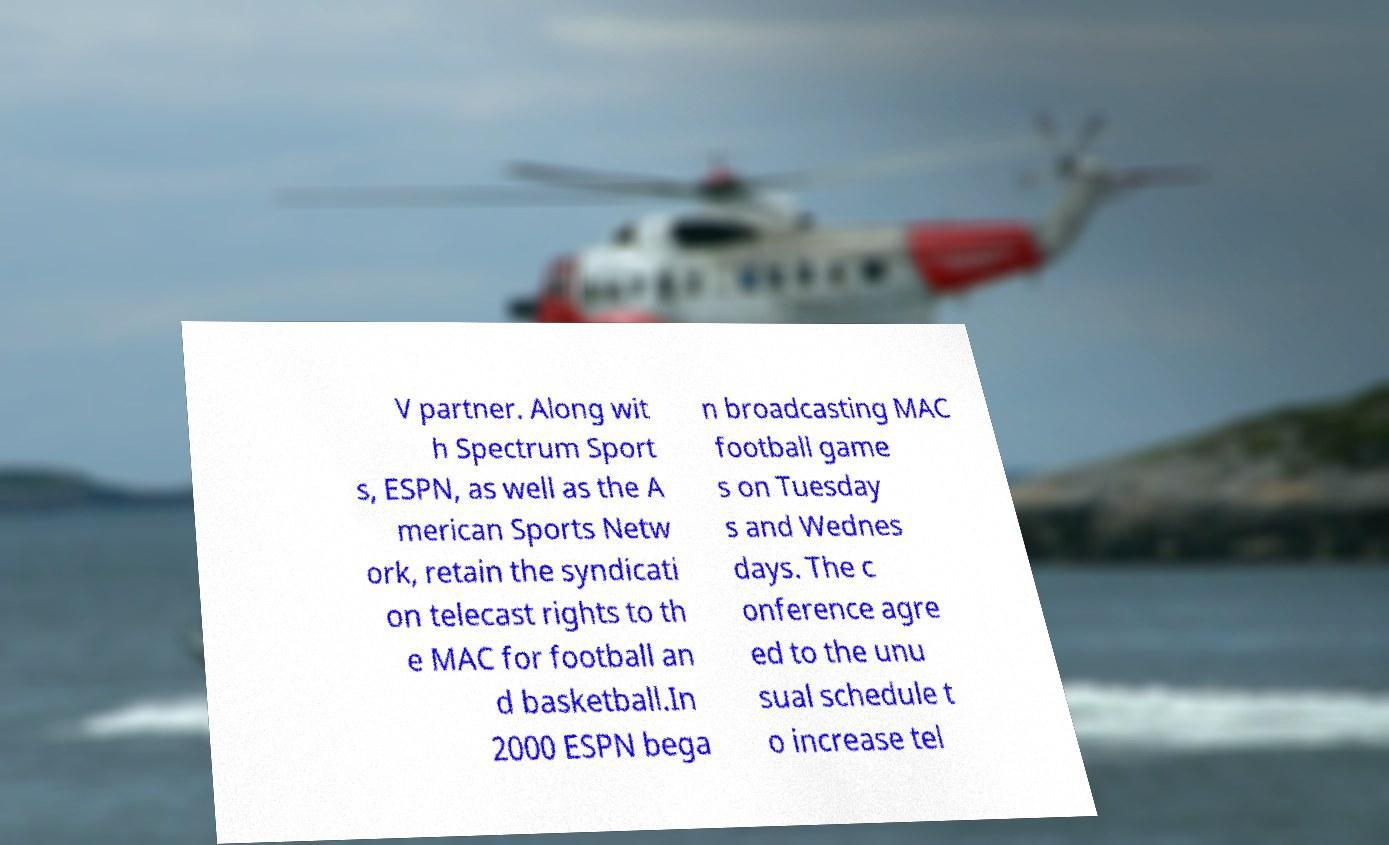What messages or text are displayed in this image? I need them in a readable, typed format. V partner. Along wit h Spectrum Sport s, ESPN, as well as the A merican Sports Netw ork, retain the syndicati on telecast rights to th e MAC for football an d basketball.In 2000 ESPN bega n broadcasting MAC football game s on Tuesday s and Wednes days. The c onference agre ed to the unu sual schedule t o increase tel 